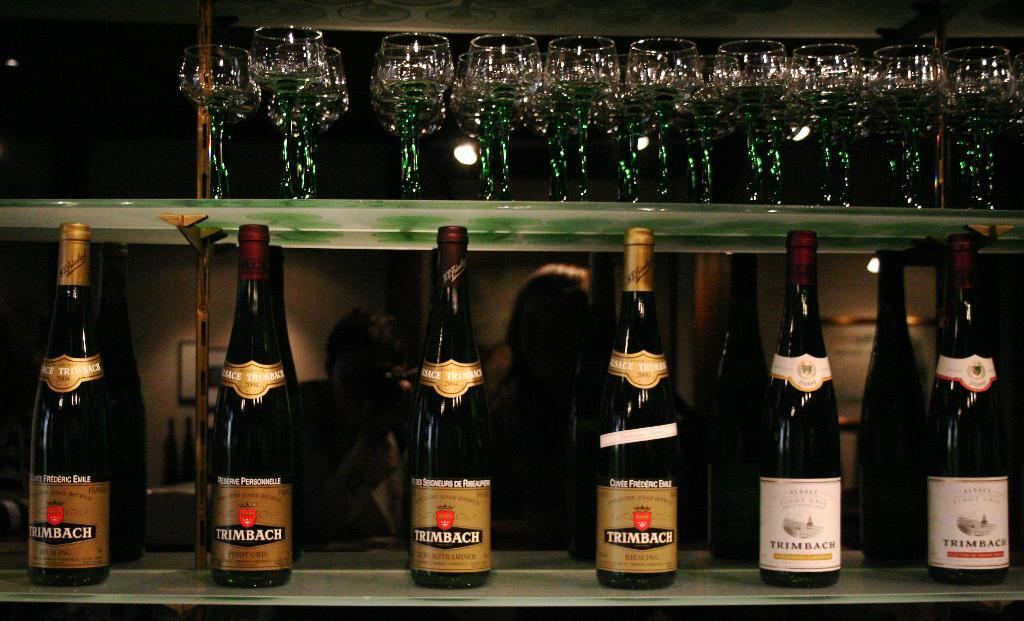<image>
Relay a brief, clear account of the picture shown. Six bottles of Trimbach are sitting next to each other at the bar. 